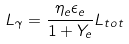Convert formula to latex. <formula><loc_0><loc_0><loc_500><loc_500>L _ { \gamma } = \frac { \eta _ { e } \epsilon _ { e } } { 1 + Y _ { e } } L _ { t o t }</formula> 